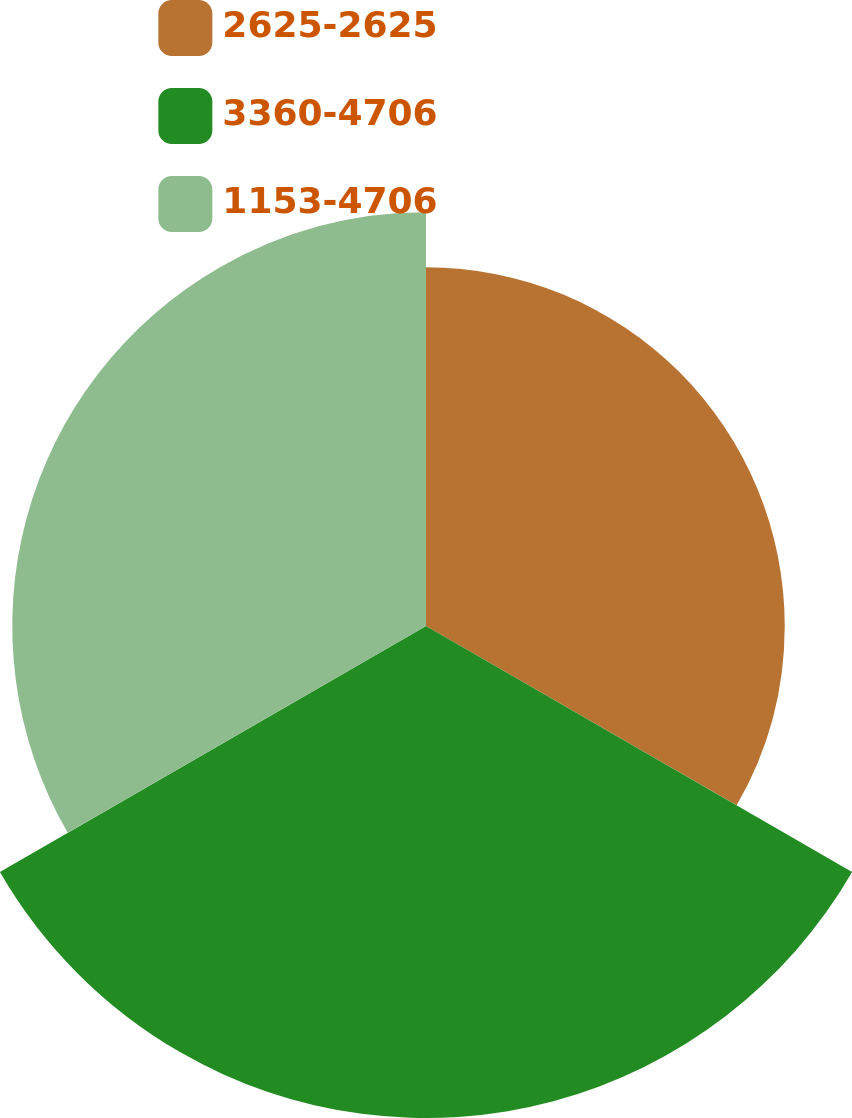<chart> <loc_0><loc_0><loc_500><loc_500><pie_chart><fcel>2625-2625<fcel>3360-4706<fcel>1153-4706<nl><fcel>28.37%<fcel>38.91%<fcel>32.72%<nl></chart> 